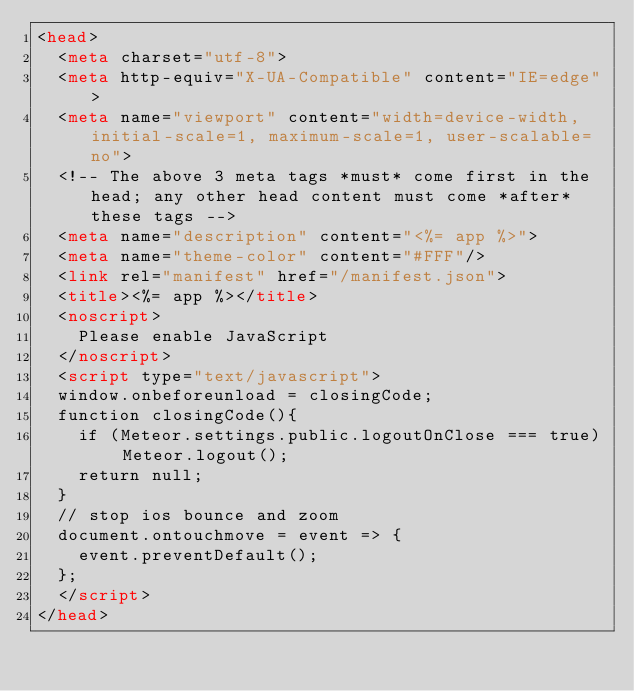<code> <loc_0><loc_0><loc_500><loc_500><_HTML_><head>
  <meta charset="utf-8">
  <meta http-equiv="X-UA-Compatible" content="IE=edge">
  <meta name="viewport" content="width=device-width, initial-scale=1, maximum-scale=1, user-scalable=no">
  <!-- The above 3 meta tags *must* come first in the head; any other head content must come *after* these tags -->
  <meta name="description" content="<%= app %>">
  <meta name="theme-color" content="#FFF"/>
  <link rel="manifest" href="/manifest.json">
  <title><%= app %></title>
  <noscript>
    Please enable JavaScript
  </noscript>
  <script type="text/javascript">
  window.onbeforeunload = closingCode;
  function closingCode(){
    if (Meteor.settings.public.logoutOnClose === true) Meteor.logout();
    return null;
  }
  // stop ios bounce and zoom 
  document.ontouchmove = event => {
    event.preventDefault();
  }; 
  </script>
</head>
</code> 